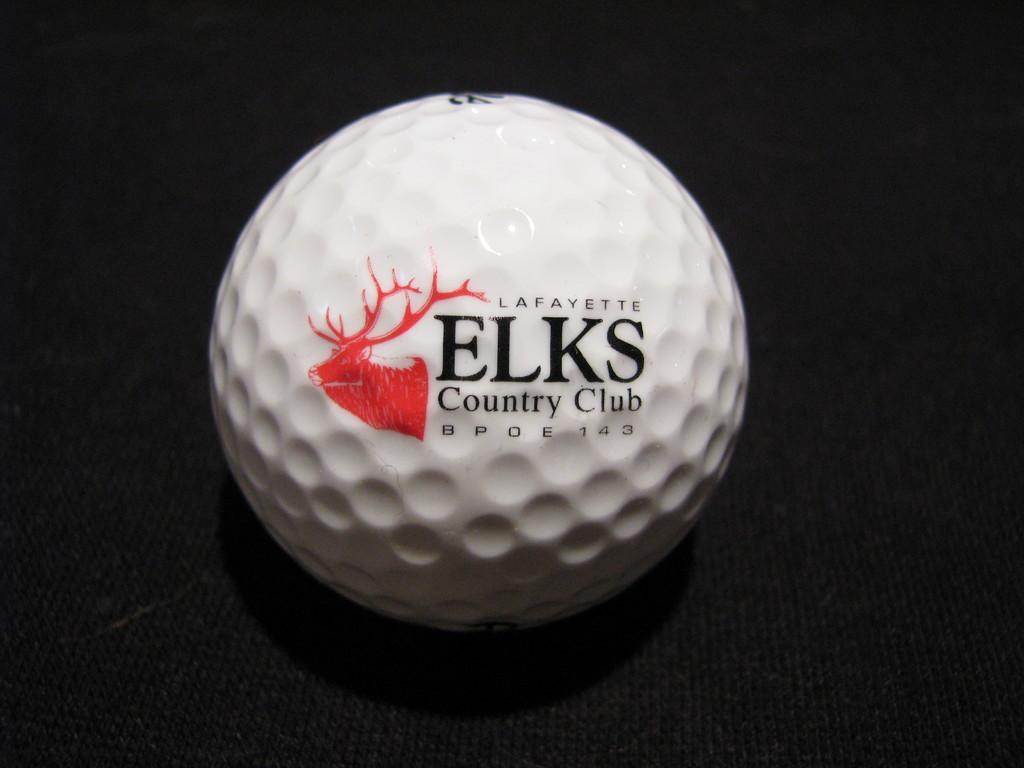In one or two sentences, can you explain what this image depicts? In this image in the center there is one ball, on the ball there is some text and at the bottom there is table. 